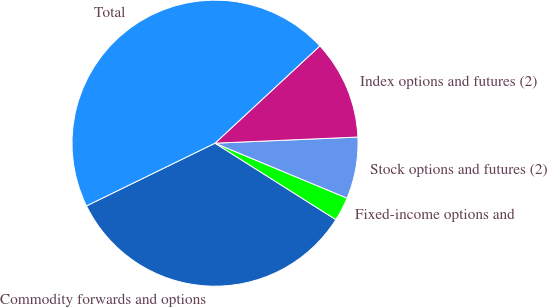<chart> <loc_0><loc_0><loc_500><loc_500><pie_chart><fcel>Commodity forwards and options<fcel>Fixed-income options and<fcel>Stock options and futures (2)<fcel>Index options and futures (2)<fcel>Total<nl><fcel>33.8%<fcel>2.7%<fcel>6.96%<fcel>11.22%<fcel>45.32%<nl></chart> 